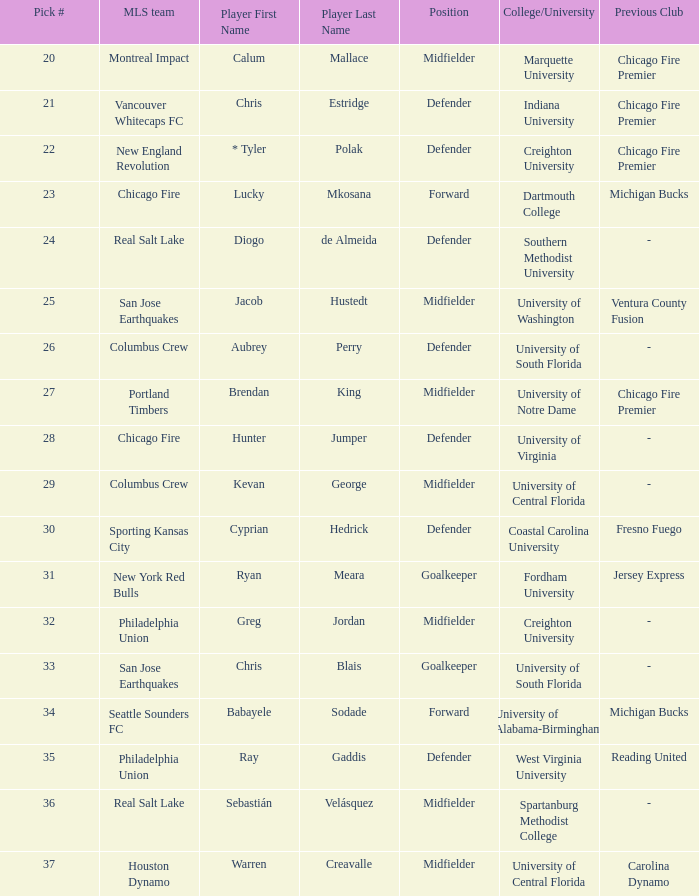Which mls team selected babayele sodade? Seattle Sounders FC. 